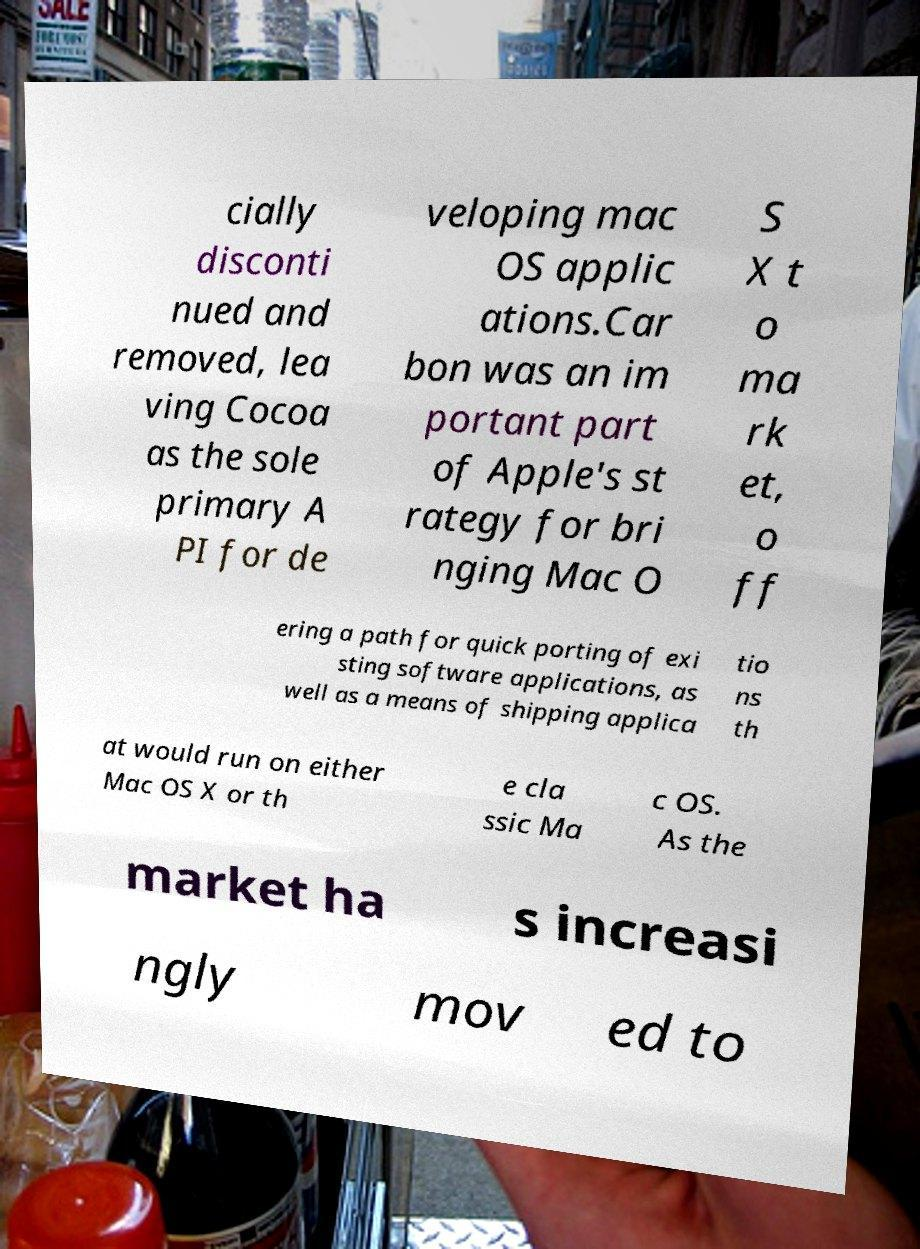There's text embedded in this image that I need extracted. Can you transcribe it verbatim? cially disconti nued and removed, lea ving Cocoa as the sole primary A PI for de veloping mac OS applic ations.Car bon was an im portant part of Apple's st rategy for bri nging Mac O S X t o ma rk et, o ff ering a path for quick porting of exi sting software applications, as well as a means of shipping applica tio ns th at would run on either Mac OS X or th e cla ssic Ma c OS. As the market ha s increasi ngly mov ed to 